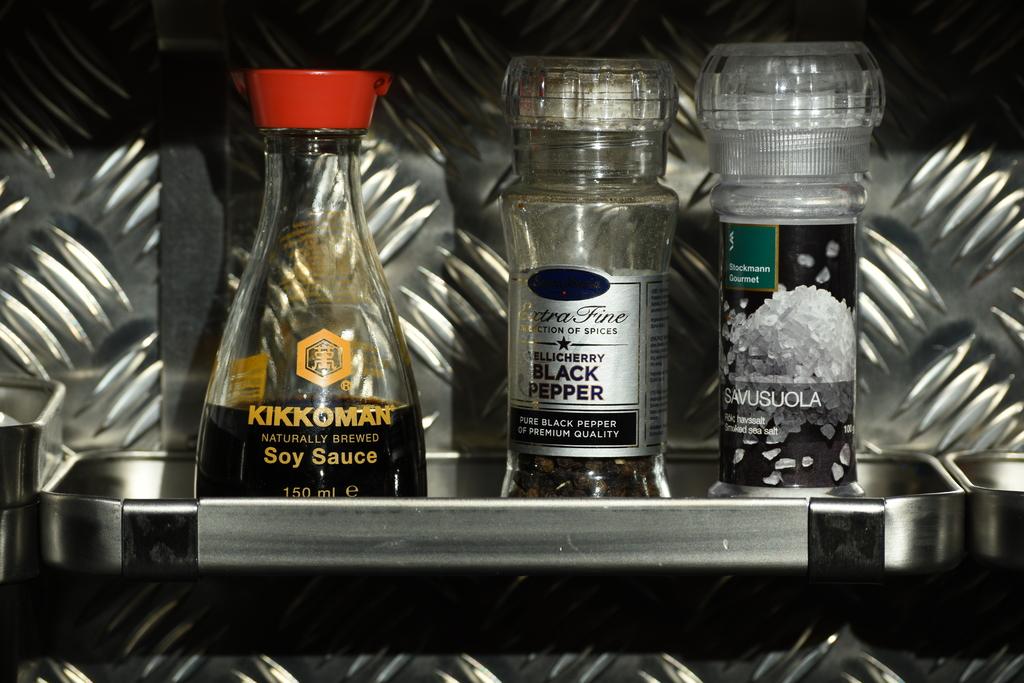What kind of pepper is mentioned on the bottle in the middle?
Your response must be concise. Black. 